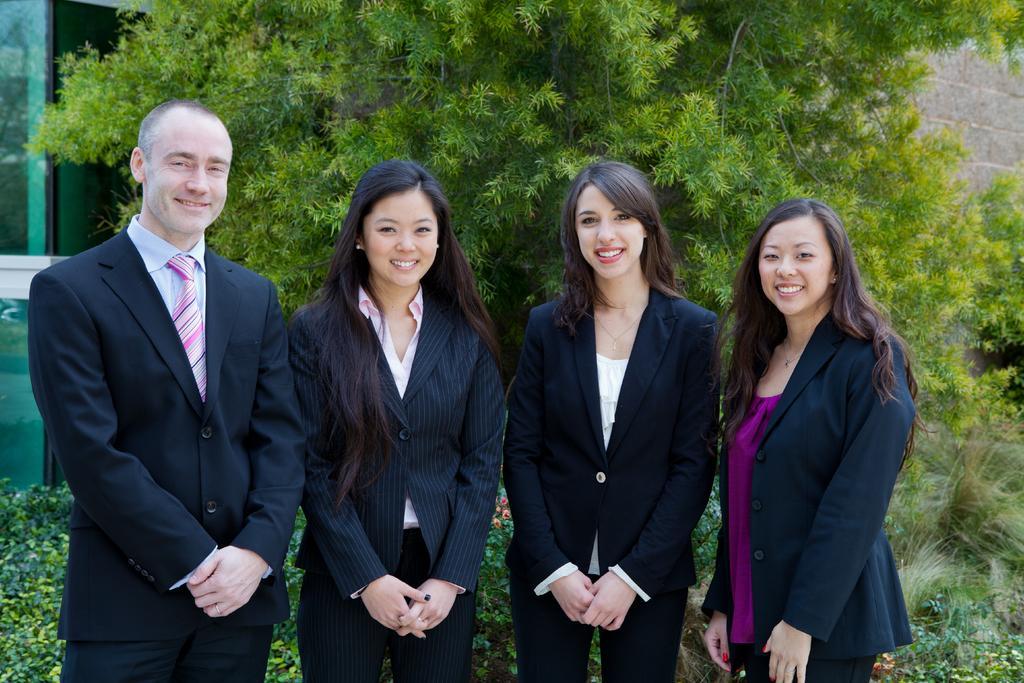Can you describe this image briefly? In this image, we can see four persons are standing side by side. They are watching and smiling. Background we can see plants, trees, walls and glass objects. 